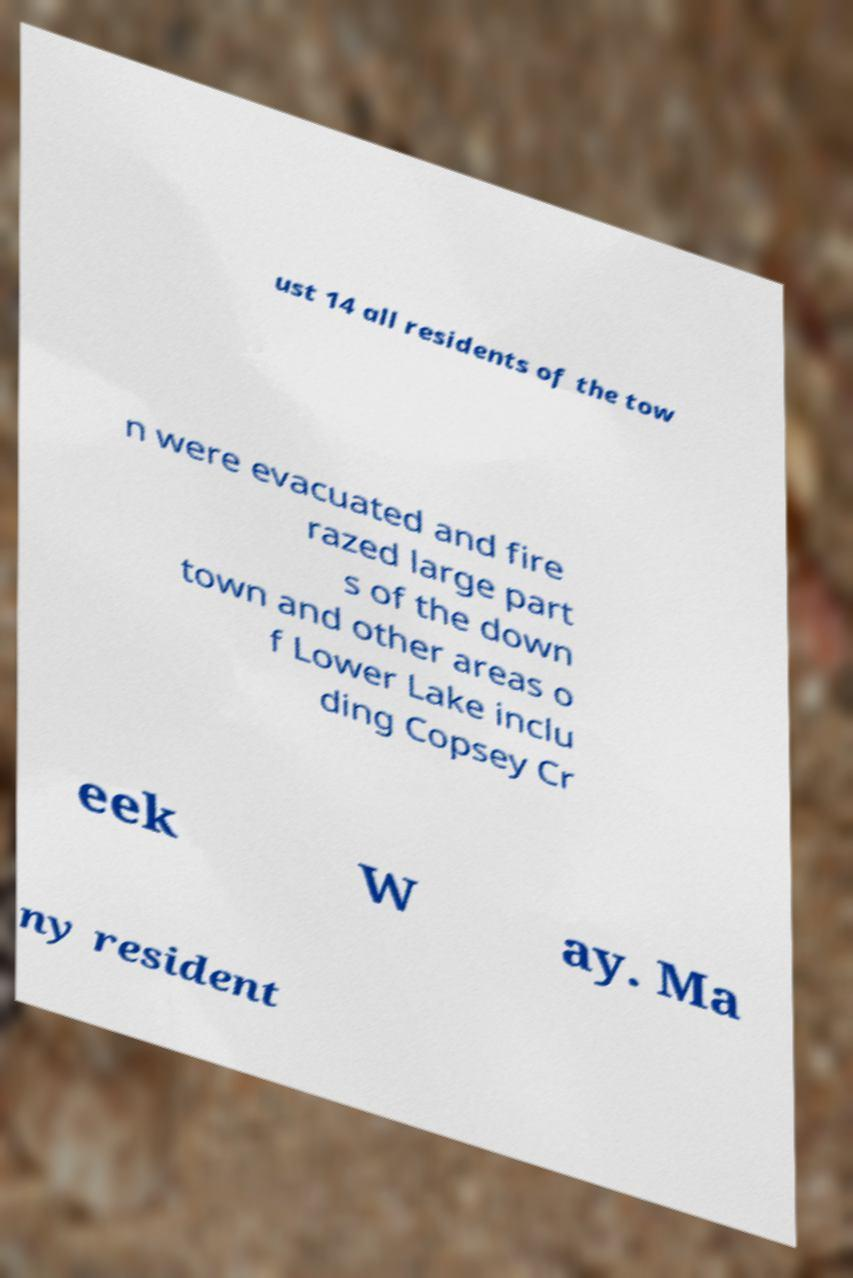For documentation purposes, I need the text within this image transcribed. Could you provide that? ust 14 all residents of the tow n were evacuated and fire razed large part s of the down town and other areas o f Lower Lake inclu ding Copsey Cr eek W ay. Ma ny resident 